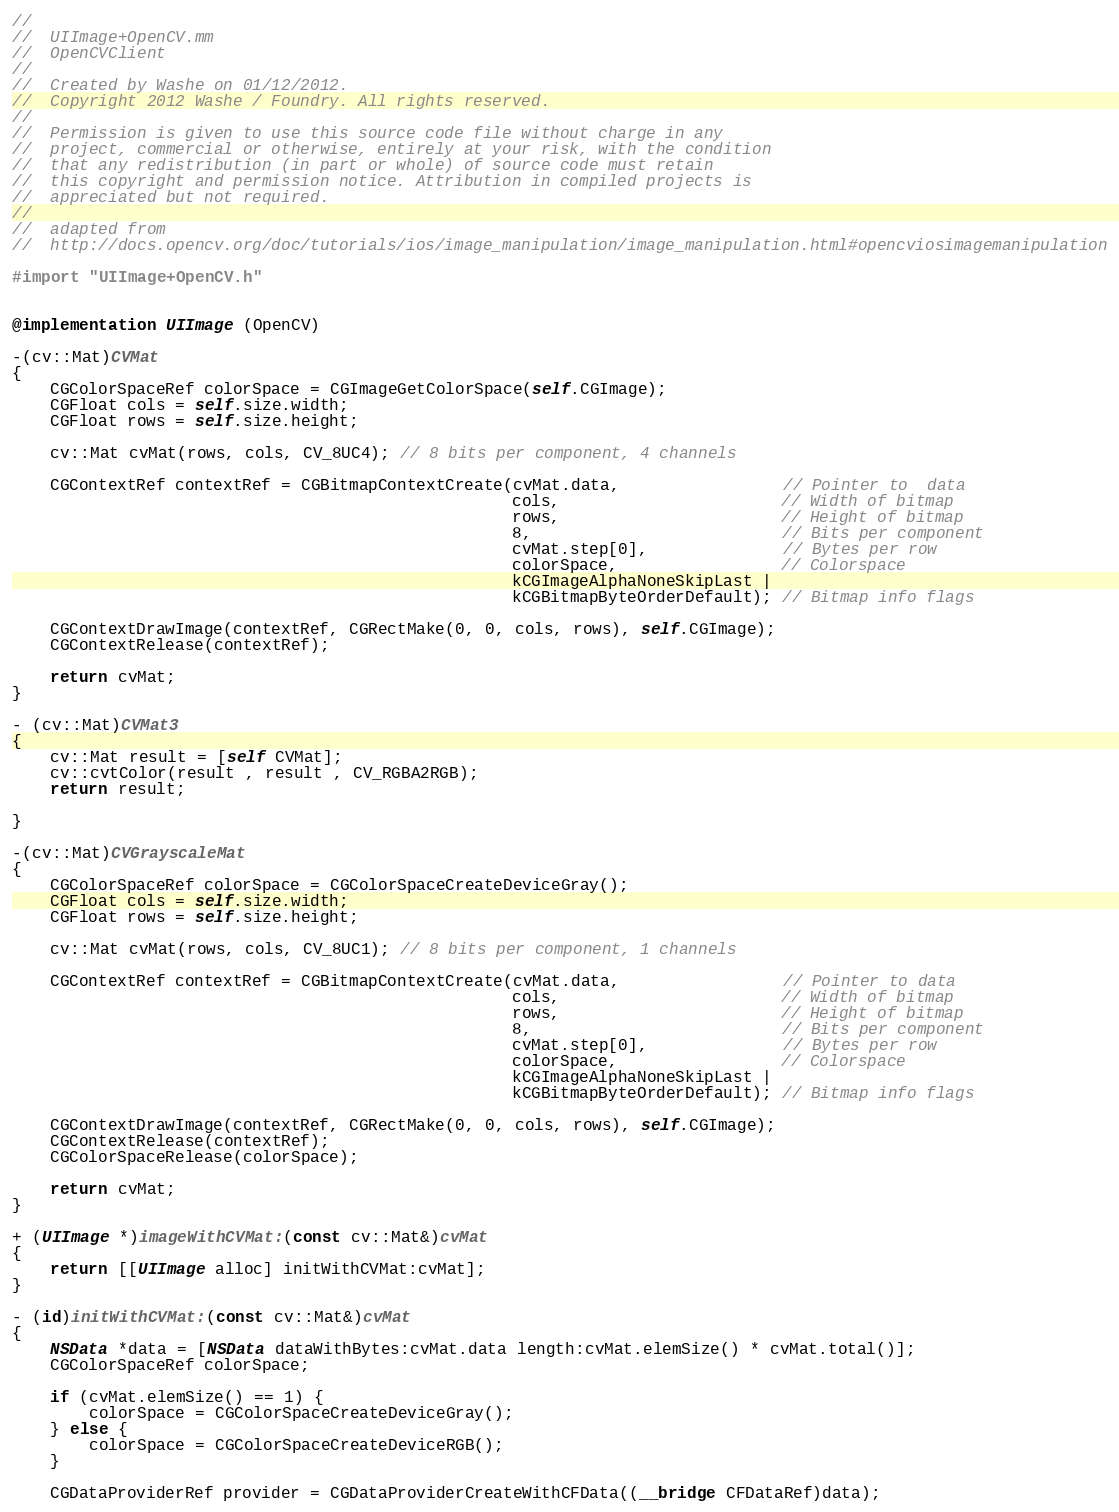Convert code to text. <code><loc_0><loc_0><loc_500><loc_500><_ObjectiveC_>//
//  UIImage+OpenCV.mm
//  OpenCVClient
//
//  Created by Washe on 01/12/2012.
//  Copyright 2012 Washe / Foundry. All rights reserved.
//
//  Permission is given to use this source code file without charge in any
//  project, commercial or otherwise, entirely at your risk, with the condition
//  that any redistribution (in part or whole) of source code must retain
//  this copyright and permission notice. Attribution in compiled projects is
//  appreciated but not required.
//
//  adapted from
//  http://docs.opencv.org/doc/tutorials/ios/image_manipulation/image_manipulation.html#opencviosimagemanipulation

#import "UIImage+OpenCV.h"


@implementation UIImage (OpenCV)

-(cv::Mat)CVMat
{
    CGColorSpaceRef colorSpace = CGImageGetColorSpace(self.CGImage);
    CGFloat cols = self.size.width;
    CGFloat rows = self.size.height;
    
    cv::Mat cvMat(rows, cols, CV_8UC4); // 8 bits per component, 4 channels
    
    CGContextRef contextRef = CGBitmapContextCreate(cvMat.data,                 // Pointer to  data
                                                    cols,                       // Width of bitmap
                                                    rows,                       // Height of bitmap
                                                    8,                          // Bits per component
                                                    cvMat.step[0],              // Bytes per row
                                                    colorSpace,                 // Colorspace
                                                    kCGImageAlphaNoneSkipLast |
                                                    kCGBitmapByteOrderDefault); // Bitmap info flags
    
    CGContextDrawImage(contextRef, CGRectMake(0, 0, cols, rows), self.CGImage);
    CGContextRelease(contextRef);
    
    return cvMat;
}

- (cv::Mat)CVMat3
{
    cv::Mat result = [self CVMat];
    cv::cvtColor(result , result , CV_RGBA2RGB);
    return result;

}

-(cv::Mat)CVGrayscaleMat
{
    CGColorSpaceRef colorSpace = CGColorSpaceCreateDeviceGray();
    CGFloat cols = self.size.width;
    CGFloat rows = self.size.height;
    
    cv::Mat cvMat(rows, cols, CV_8UC1); // 8 bits per component, 1 channels
    
    CGContextRef contextRef = CGBitmapContextCreate(cvMat.data,                 // Pointer to data
                                                    cols,                       // Width of bitmap
                                                    rows,                       // Height of bitmap
                                                    8,                          // Bits per component
                                                    cvMat.step[0],              // Bytes per row
                                                    colorSpace,                 // Colorspace
                                                    kCGImageAlphaNoneSkipLast |
                                                    kCGBitmapByteOrderDefault); // Bitmap info flags
    
    CGContextDrawImage(contextRef, CGRectMake(0, 0, cols, rows), self.CGImage);
    CGContextRelease(contextRef);
    CGColorSpaceRelease(colorSpace);
    
    return cvMat;
}

+ (UIImage *)imageWithCVMat:(const cv::Mat&)cvMat
{
    return [[UIImage alloc] initWithCVMat:cvMat];
}

- (id)initWithCVMat:(const cv::Mat&)cvMat
{
    NSData *data = [NSData dataWithBytes:cvMat.data length:cvMat.elemSize() * cvMat.total()];
    CGColorSpaceRef colorSpace;
    
    if (cvMat.elemSize() == 1) {
        colorSpace = CGColorSpaceCreateDeviceGray();
    } else {
        colorSpace = CGColorSpaceCreateDeviceRGB();
    }
    
    CGDataProviderRef provider = CGDataProviderCreateWithCFData((__bridge CFDataRef)data);
</code> 